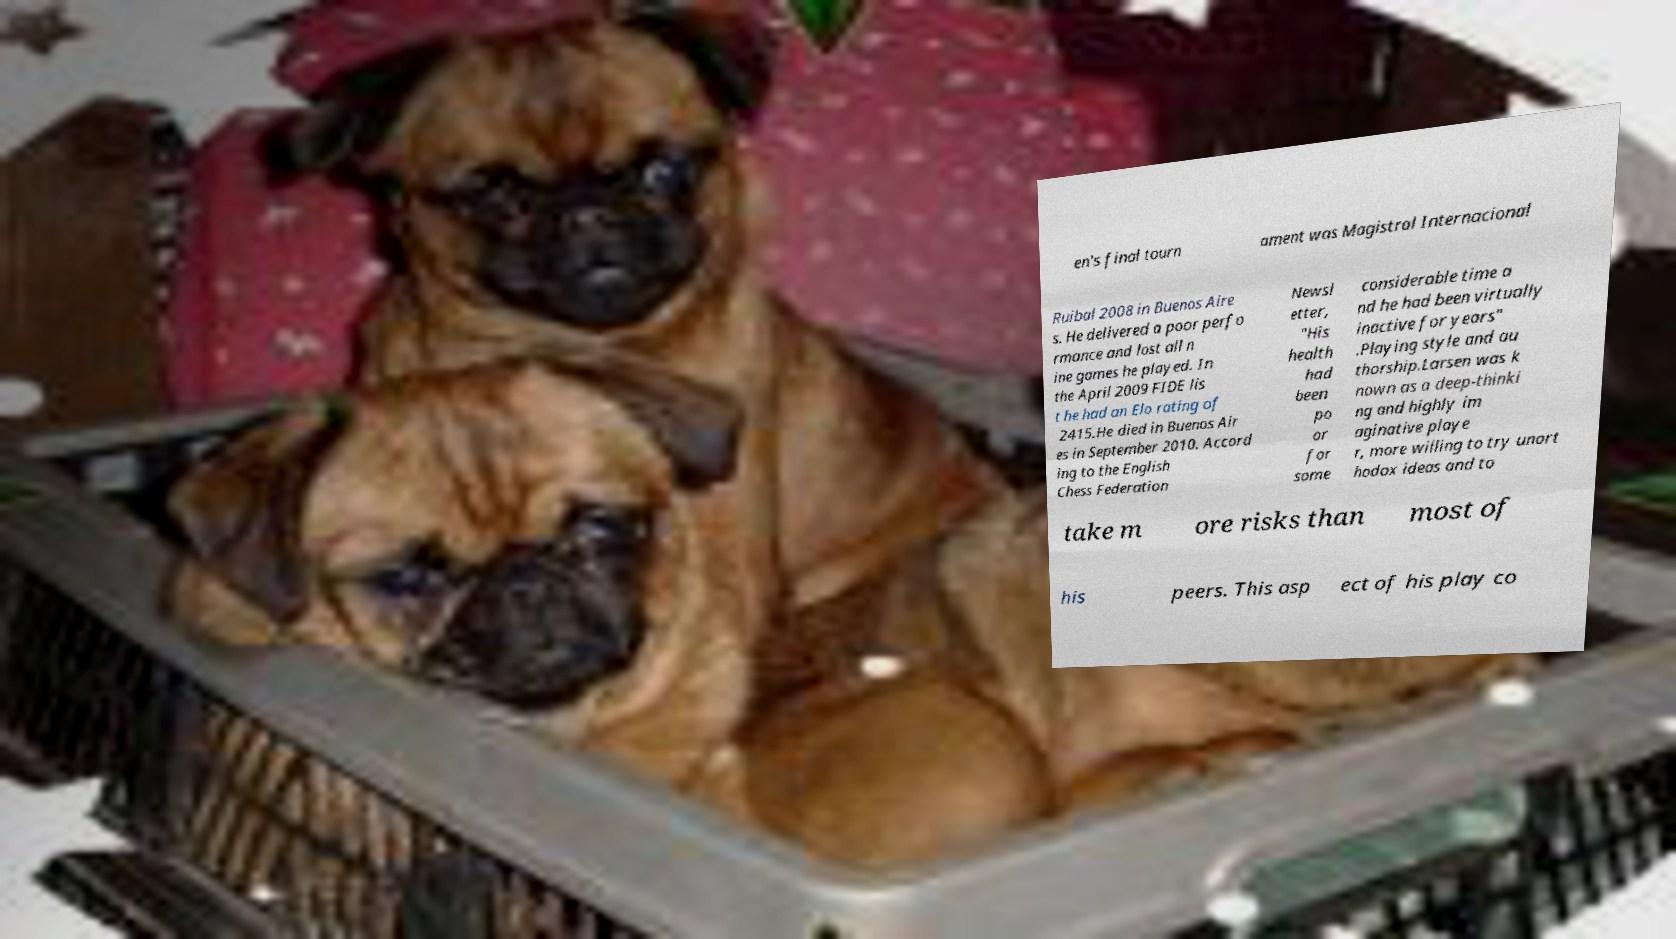Can you read and provide the text displayed in the image?This photo seems to have some interesting text. Can you extract and type it out for me? en's final tourn ament was Magistral Internacional Ruibal 2008 in Buenos Aire s. He delivered a poor perfo rmance and lost all n ine games he played. In the April 2009 FIDE lis t he had an Elo rating of 2415.He died in Buenos Air es in September 2010. Accord ing to the English Chess Federation Newsl etter, "His health had been po or for some considerable time a nd he had been virtually inactive for years" .Playing style and au thorship.Larsen was k nown as a deep-thinki ng and highly im aginative playe r, more willing to try unort hodox ideas and to take m ore risks than most of his peers. This asp ect of his play co 